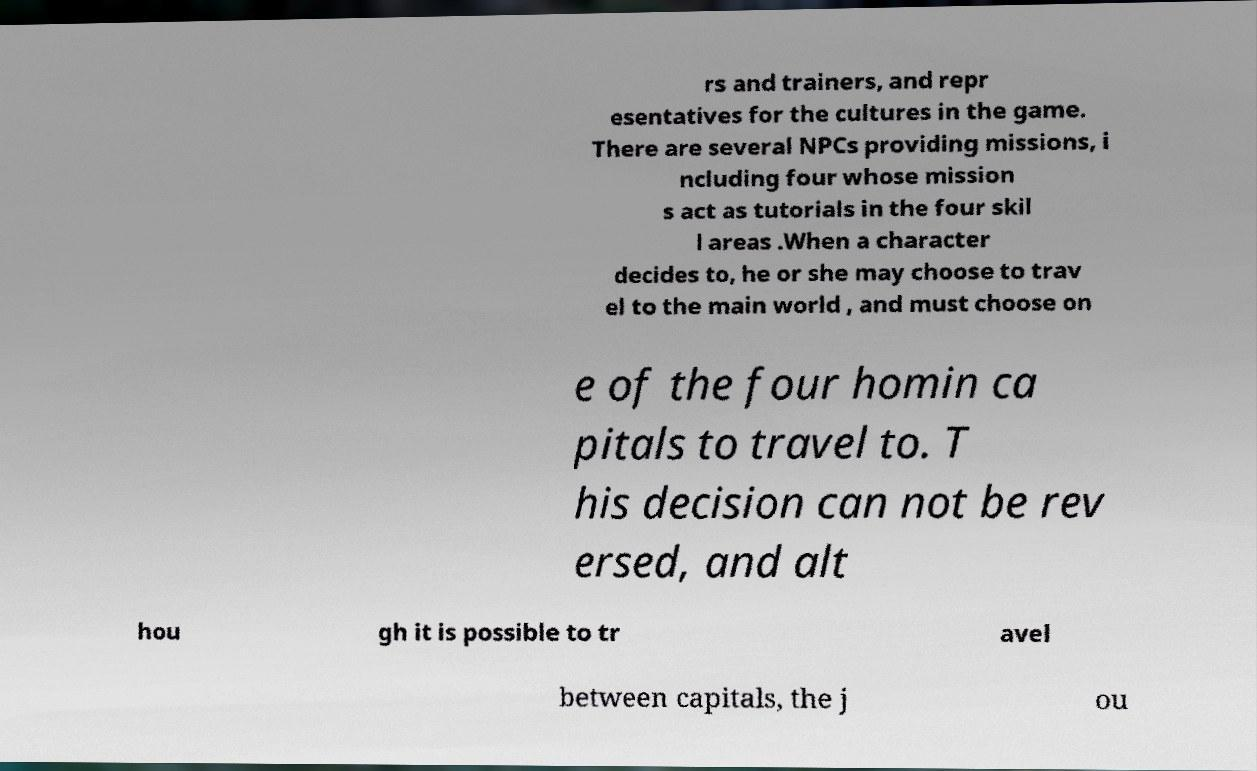What messages or text are displayed in this image? I need them in a readable, typed format. rs and trainers, and repr esentatives for the cultures in the game. There are several NPCs providing missions, i ncluding four whose mission s act as tutorials in the four skil l areas .When a character decides to, he or she may choose to trav el to the main world , and must choose on e of the four homin ca pitals to travel to. T his decision can not be rev ersed, and alt hou gh it is possible to tr avel between capitals, the j ou 